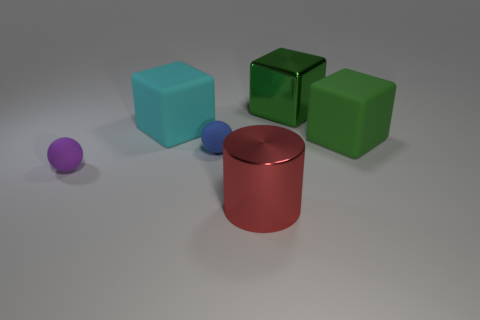There is another tiny thing that is the same shape as the small purple rubber object; what material is it?
Offer a very short reply. Rubber. Is there any other thing that is the same material as the tiny blue sphere?
Your response must be concise. Yes. There is a large red cylinder; are there any big red cylinders on the left side of it?
Offer a very short reply. No. How many large rubber things are there?
Provide a short and direct response. 2. What number of rubber cubes are on the right side of the green cube in front of the cyan matte thing?
Your answer should be very brief. 0. Do the cylinder and the big object that is to the right of the large shiny block have the same color?
Ensure brevity in your answer.  No. How many other large rubber things have the same shape as the blue matte thing?
Offer a terse response. 0. What material is the tiny sphere in front of the tiny blue rubber thing?
Provide a short and direct response. Rubber. Does the big object behind the cyan rubber block have the same shape as the cyan rubber thing?
Ensure brevity in your answer.  Yes. Are there any green metallic objects that have the same size as the red thing?
Your answer should be compact. Yes. 